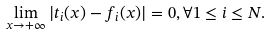Convert formula to latex. <formula><loc_0><loc_0><loc_500><loc_500>\lim _ { x \to + \infty } | t _ { i } ( x ) - f _ { i } ( x ) | = 0 , \forall 1 \leq i \leq N .</formula> 